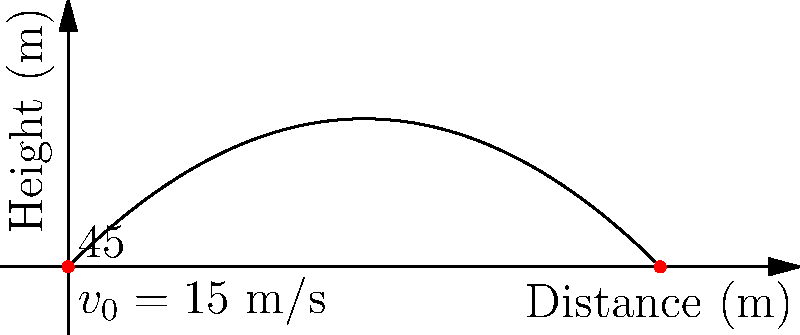You're practicing basketball shots in your backyard. You launch a ball with an initial velocity of 15 m/s at a 45° angle to the horizontal. Assuming no air resistance, what is the maximum height reached by the ball during its flight? Let's approach this step-by-step:

1) The maximum height is reached when the vertical component of velocity becomes zero.

2) We can use the equation: $v_y = v_{0y} - gt$
   Where $v_y$ is the vertical velocity, $v_{0y}$ is the initial vertical velocity, $g$ is the acceleration due to gravity, and $t$ is the time.

3) At the highest point, $v_y = 0$, so:
   $0 = v_{0y} - gt_{max}$

4) We know that $v_{0y} = v_0 \sin \theta = 15 \sin 45° = 15 \cdot \frac{\sqrt{2}}{2} \approx 10.61$ m/s

5) Solving for $t_{max}$:
   $t_{max} = \frac{v_{0y}}{g} = \frac{10.61}{9.8} \approx 1.08$ seconds

6) Now we can use the equation for height: $h = v_{0y}t - \frac{1}{2}gt^2$

7) Substituting our values:
   $h_{max} = 10.61 \cdot 1.08 - \frac{1}{2} \cdot 9.8 \cdot 1.08^2$
   $h_{max} = 11.46 - 5.73 = 5.73$ meters

Therefore, the maximum height reached by the ball is approximately 5.73 meters.
Answer: 5.73 meters 